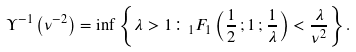Convert formula to latex. <formula><loc_0><loc_0><loc_500><loc_500>\Upsilon ^ { - 1 } \left ( \nu ^ { - 2 } \right ) = \inf \left \{ \lambda > 1 \colon _ { 1 } F _ { 1 } \left ( \frac { 1 } { 2 } \, ; 1 \, ; \frac { 1 } { \lambda } \right ) < \frac { \lambda } { \nu ^ { 2 } } \right \} .</formula> 